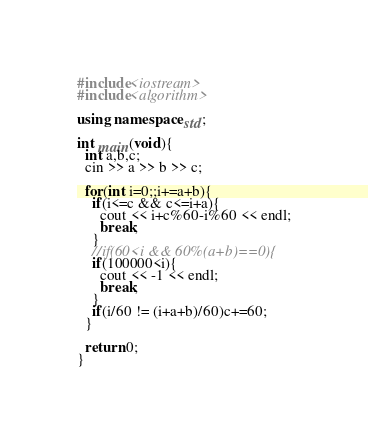<code> <loc_0><loc_0><loc_500><loc_500><_C++_>#include<iostream>
#include<algorithm>

using namespace std;

int main(void){
  int a,b,c;
  cin >> a >> b >> c;

  for(int i=0;;i+=a+b){
    if(i<=c && c<=i+a){
      cout << i+c%60-i%60 << endl;
      break;
    }
    //if(60<i && 60%(a+b)==0){
    if(100000<i){
      cout << -1 << endl;
      break;
    }
    if(i/60 != (i+a+b)/60)c+=60;
  }
  
  return 0;
}</code> 